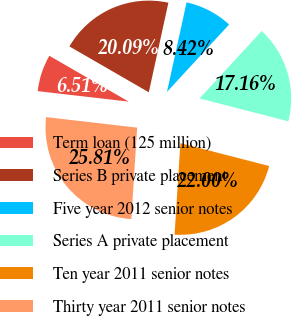Convert chart to OTSL. <chart><loc_0><loc_0><loc_500><loc_500><pie_chart><fcel>Term loan (125 million)<fcel>Series B private placement<fcel>Five year 2012 senior notes<fcel>Series A private placement<fcel>Ten year 2011 senior notes<fcel>Thirty year 2011 senior notes<nl><fcel>6.51%<fcel>20.09%<fcel>8.42%<fcel>17.16%<fcel>22.0%<fcel>25.81%<nl></chart> 